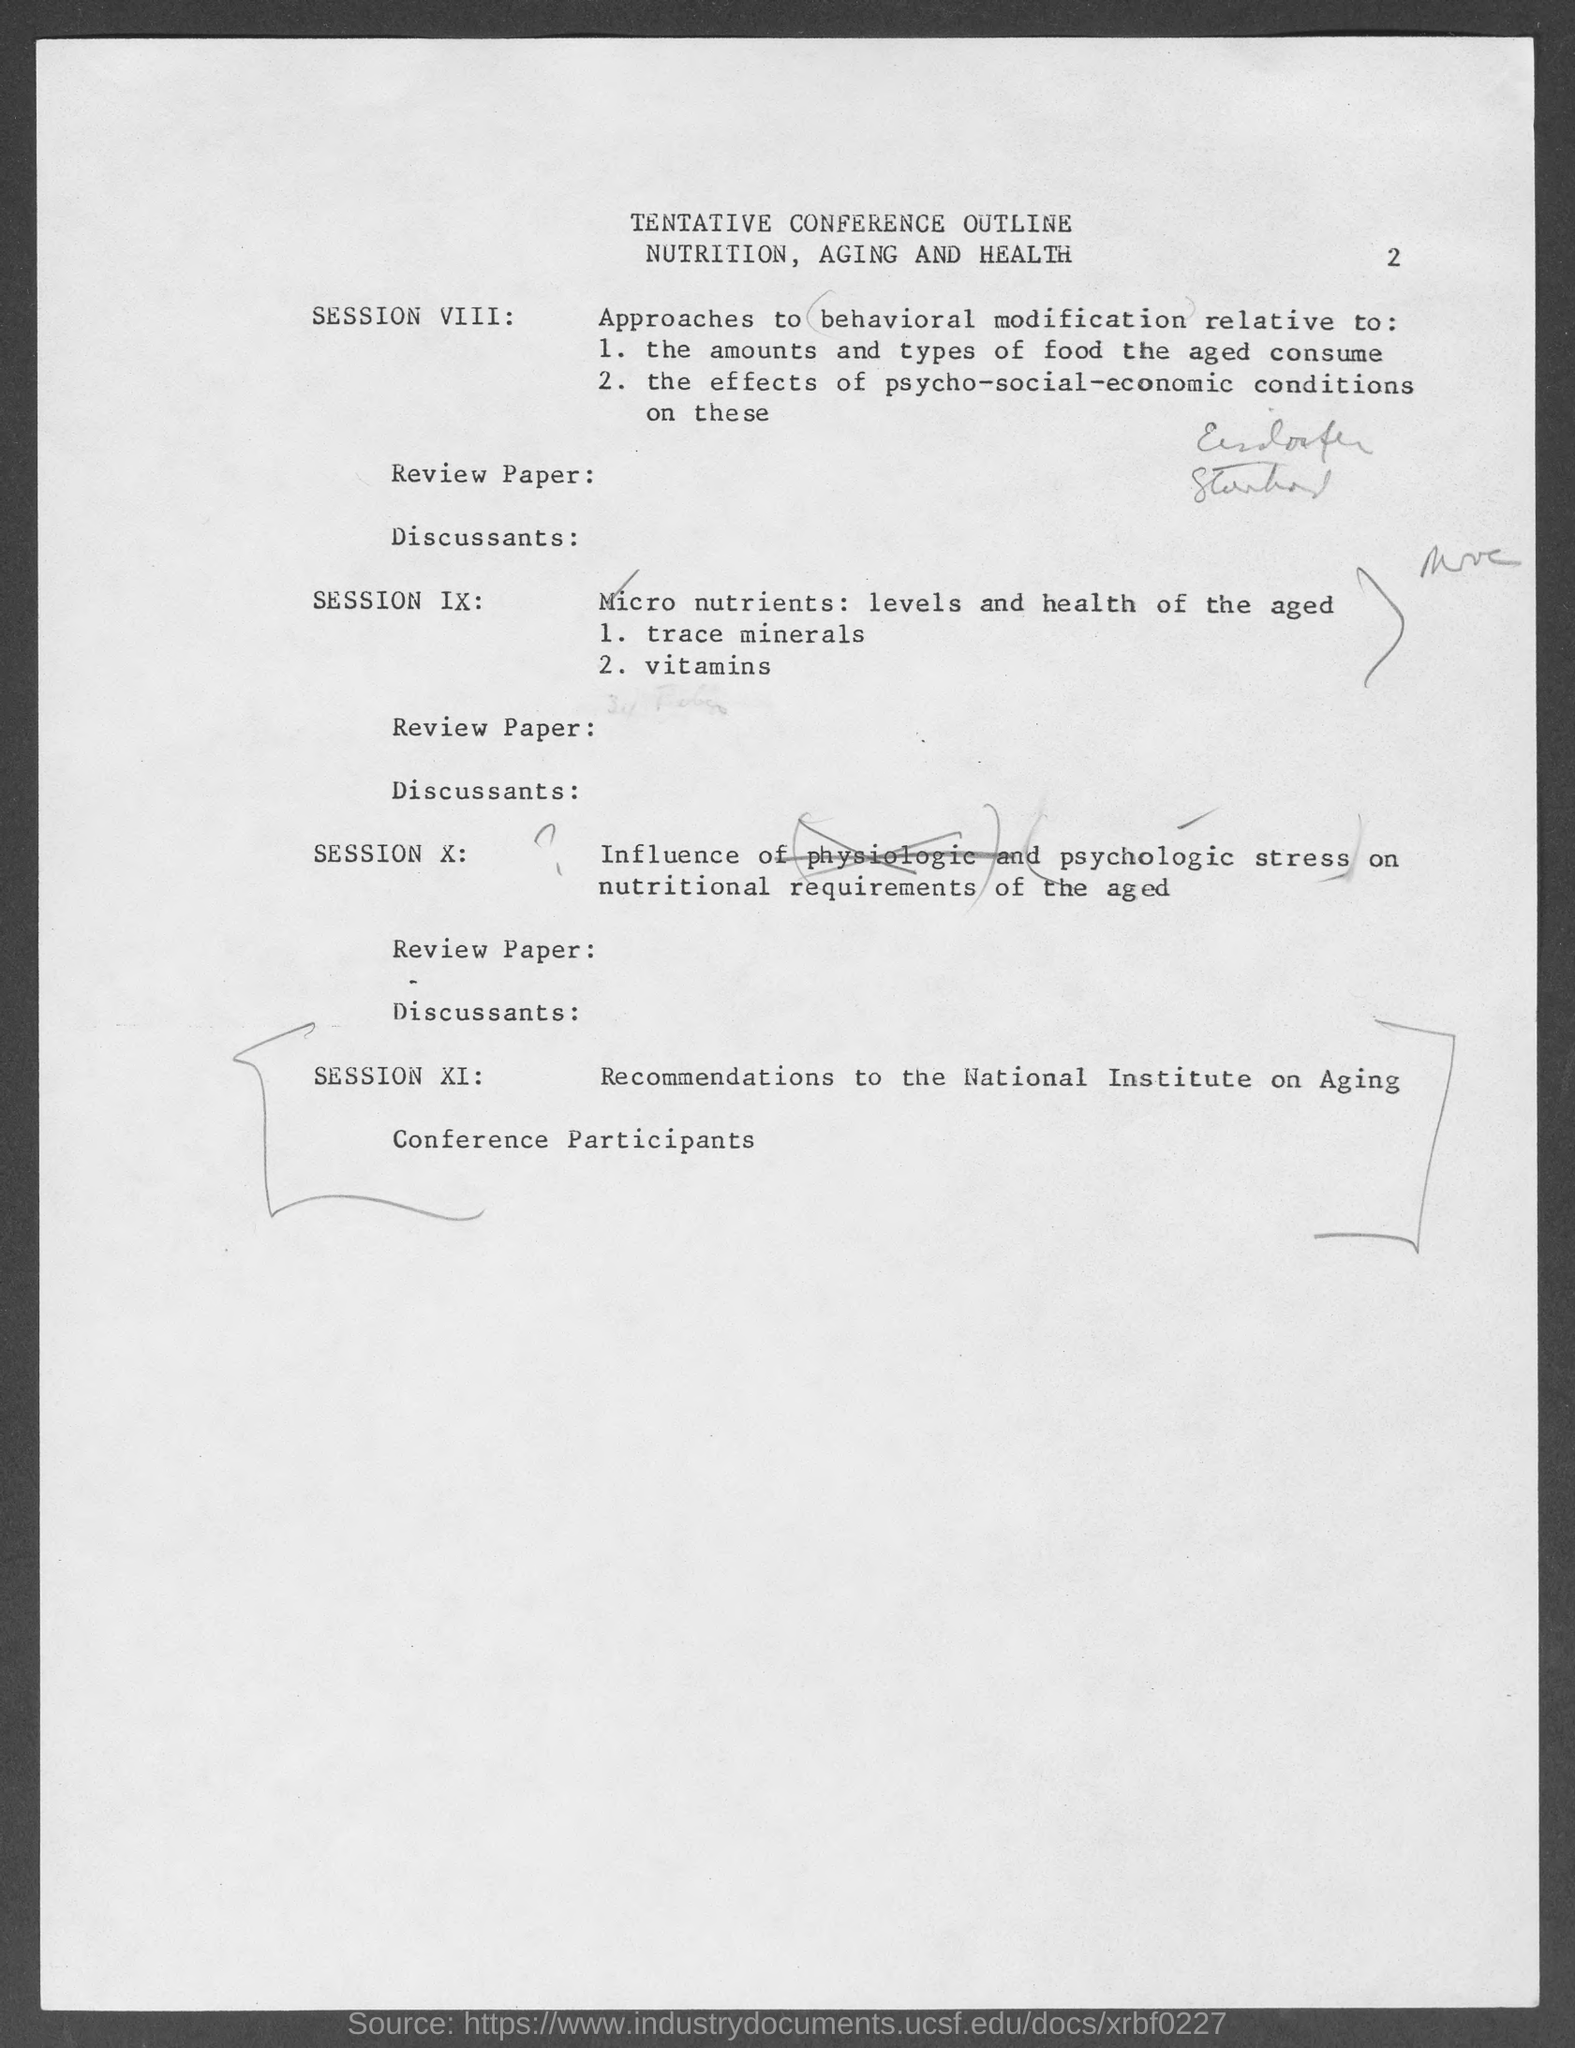What is the page number at top of the page?
Your answer should be very brief. 2. 